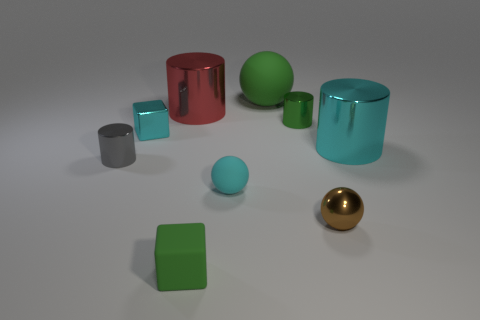Are there any things that have the same size as the green ball?
Ensure brevity in your answer.  Yes. What is the color of the tiny metallic thing that is the same shape as the big green rubber object?
Provide a succinct answer. Brown. Are there any large objects right of the tiny green rubber thing in front of the large green ball?
Give a very brief answer. Yes. Do the green rubber thing behind the small brown object and the brown shiny object have the same shape?
Provide a short and direct response. Yes. The gray thing is what shape?
Ensure brevity in your answer.  Cylinder. How many brown spheres have the same material as the tiny green cube?
Make the answer very short. 0. There is a rubber cube; is it the same color as the tiny cylinder that is on the right side of the green rubber cube?
Ensure brevity in your answer.  Yes. What number of blue spheres are there?
Offer a very short reply. 0. Are there any large objects of the same color as the tiny shiny cube?
Make the answer very short. Yes. There is a metal object behind the small cylinder behind the metal cylinder that is to the right of the tiny brown metal sphere; what is its color?
Provide a short and direct response. Red. 